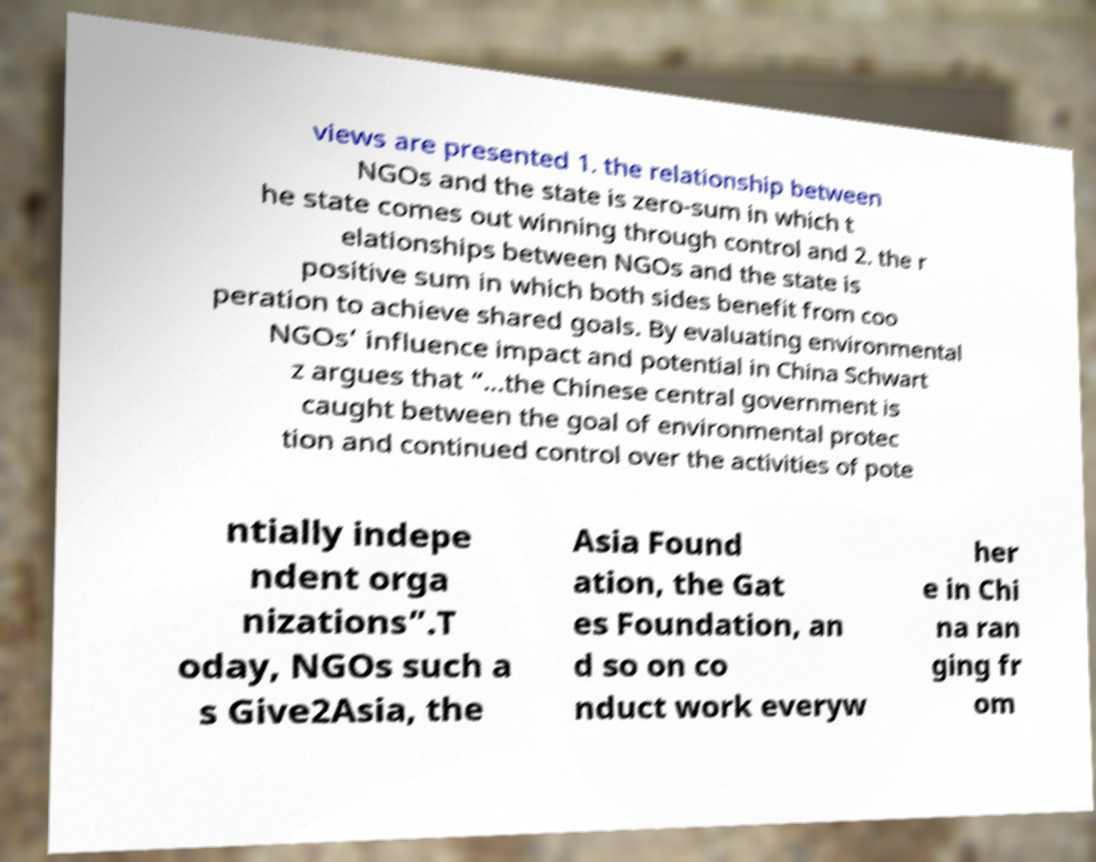Could you assist in decoding the text presented in this image and type it out clearly? views are presented 1. the relationship between NGOs and the state is zero-sum in which t he state comes out winning through control and 2. the r elationships between NGOs and the state is positive sum in which both sides benefit from coo peration to achieve shared goals. By evaluating environmental NGOs’ influence impact and potential in China Schwart z argues that “...the Chinese central government is caught between the goal of environmental protec tion and continued control over the activities of pote ntially indepe ndent orga nizations”.T oday, NGOs such a s Give2Asia, the Asia Found ation, the Gat es Foundation, an d so on co nduct work everyw her e in Chi na ran ging fr om 